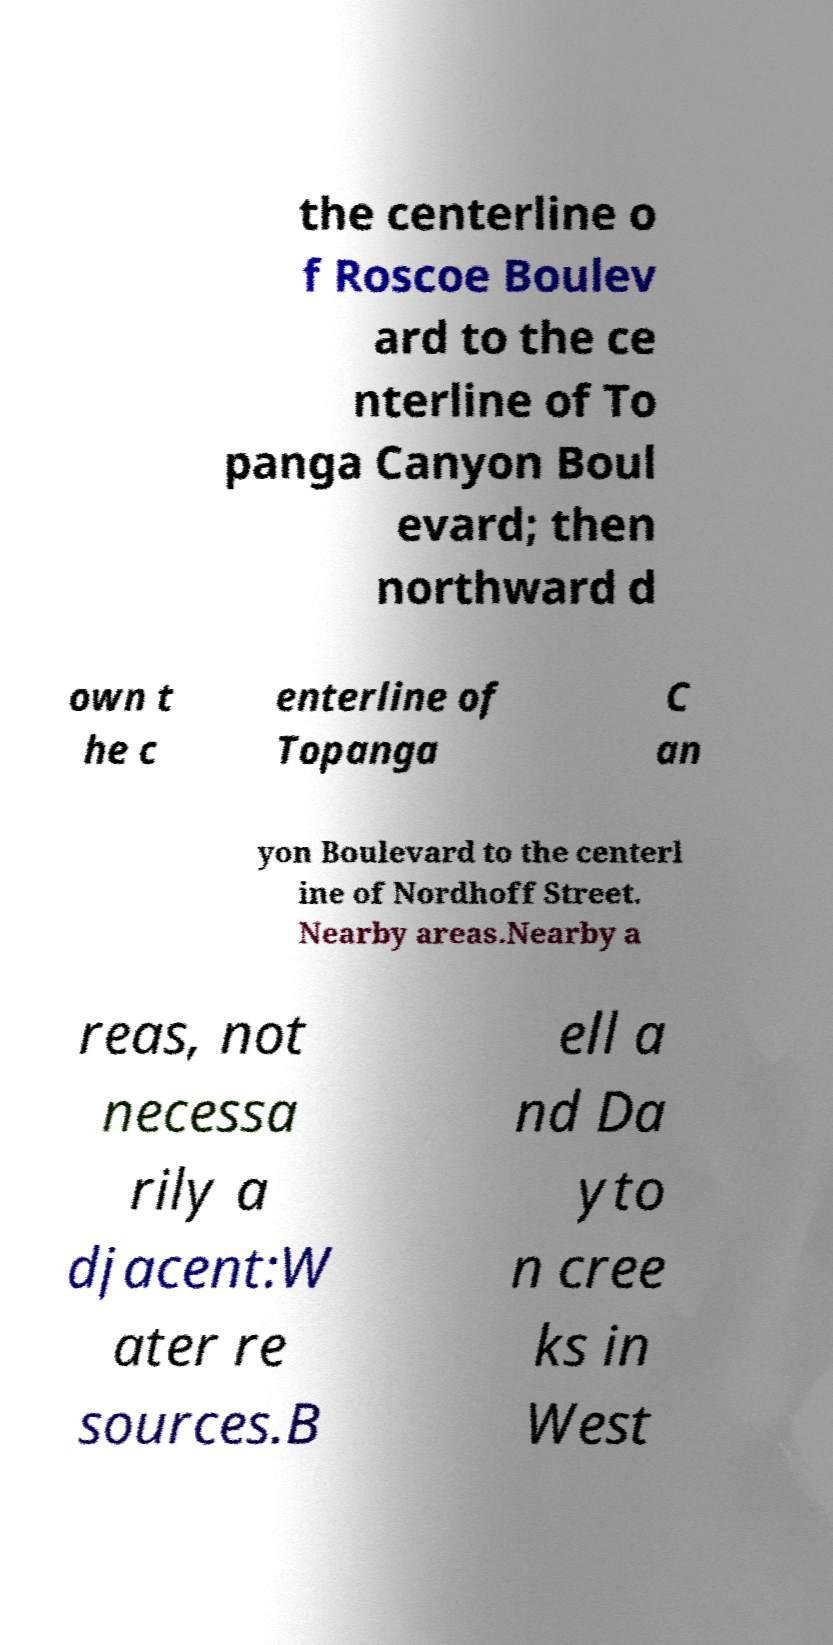Can you read and provide the text displayed in the image?This photo seems to have some interesting text. Can you extract and type it out for me? the centerline o f Roscoe Boulev ard to the ce nterline of To panga Canyon Boul evard; then northward d own t he c enterline of Topanga C an yon Boulevard to the centerl ine of Nordhoff Street. Nearby areas.Nearby a reas, not necessa rily a djacent:W ater re sources.B ell a nd Da yto n cree ks in West 